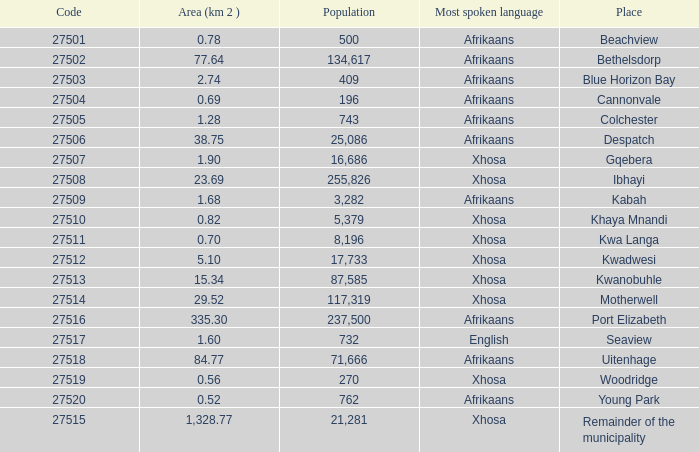What is the place that speaks xhosa, has a population less than 87,585, an area smaller than 1.28 squared kilometers, and a code larger than 27504? Khaya Mnandi, Kwa Langa, Woodridge. 